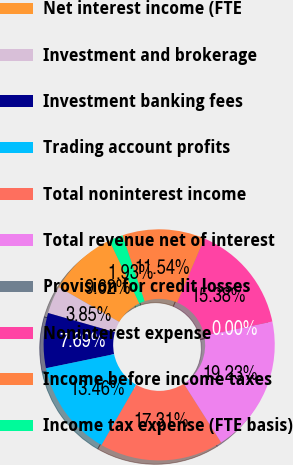Convert chart. <chart><loc_0><loc_0><loc_500><loc_500><pie_chart><fcel>Net interest income (FTE<fcel>Investment and brokerage<fcel>Investment banking fees<fcel>Trading account profits<fcel>Total noninterest income<fcel>Total revenue net of interest<fcel>Provision for credit losses<fcel>Noninterest expense<fcel>Income before income taxes<fcel>Income tax expense (FTE basis)<nl><fcel>9.62%<fcel>3.85%<fcel>7.69%<fcel>13.46%<fcel>17.31%<fcel>19.23%<fcel>0.0%<fcel>15.38%<fcel>11.54%<fcel>1.93%<nl></chart> 